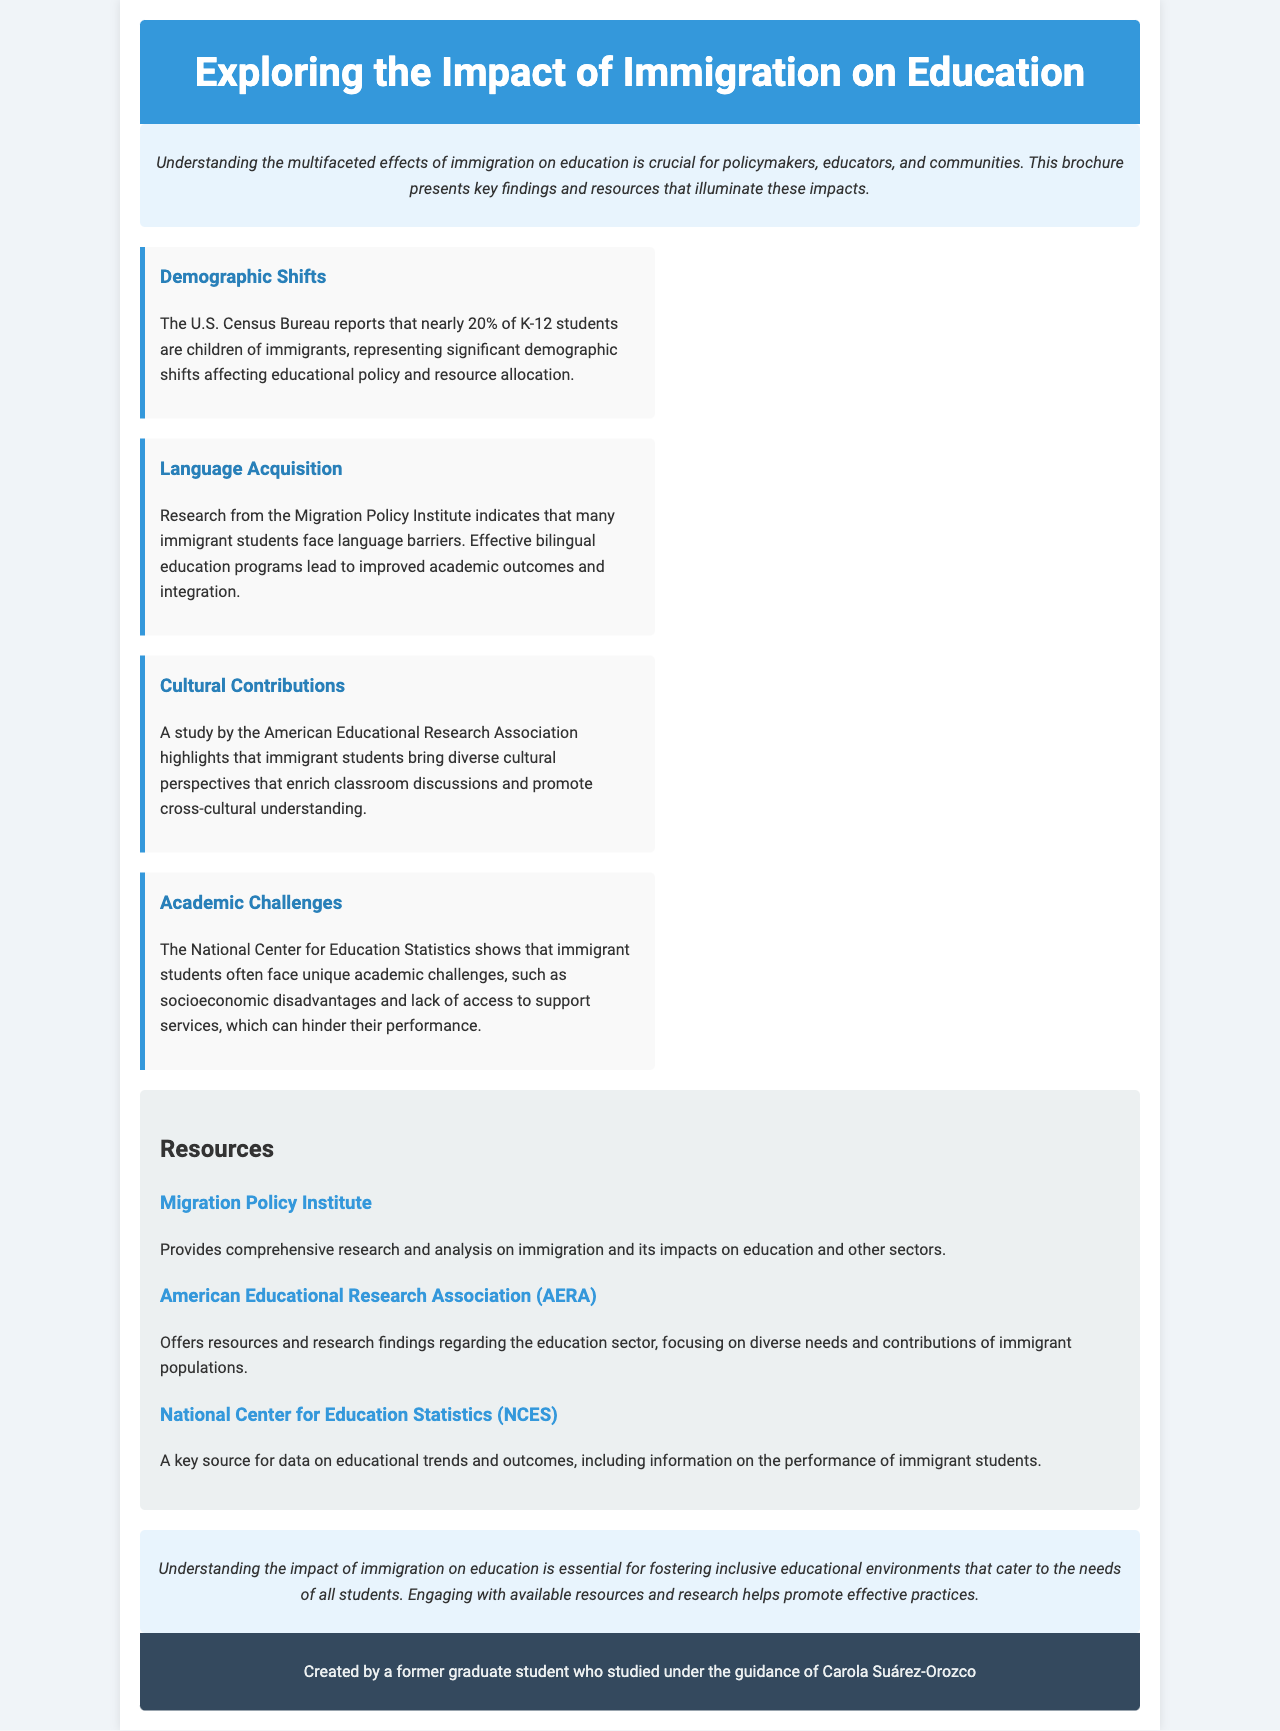What percentage of K-12 students are children of immigrants? The document states that nearly 20% of K-12 students are children of immigrants.
Answer: 20% What organization reports on language acquisition challenges faced by immigrant students? The Migration Policy Institute is mentioned regarding language barriers faced by immigrant students.
Answer: Migration Policy Institute Which study highlights the cultural contributions of immigrant students? The American Educational Research Association conducted a study highlighting these cultural contributions.
Answer: American Educational Research Association What is a key issue impacting academic performance of immigrant students? The National Center for Education Statistics identifies socioeconomic disadvantages as a key issue.
Answer: Socioeconomic disadvantages What is the title of the brochure? The brochure explicitly states its title as “Exploring the Impact of Immigration on Education.”
Answer: Exploring the Impact of Immigration on Education How many organizations are listed as resources in the brochure? The brochure lists three organizations as resources.
Answer: Three What type of educational programs improve academic outcomes for immigrant students? Effective bilingual education programs are mentioned as improving academic outcomes.
Answer: Bilingual education programs What is the purpose of the brochure? The introduction states that the brochure aims to illuminate the multifaceted effects of immigration on education.
Answer: Illuminate the effects of immigration on education 